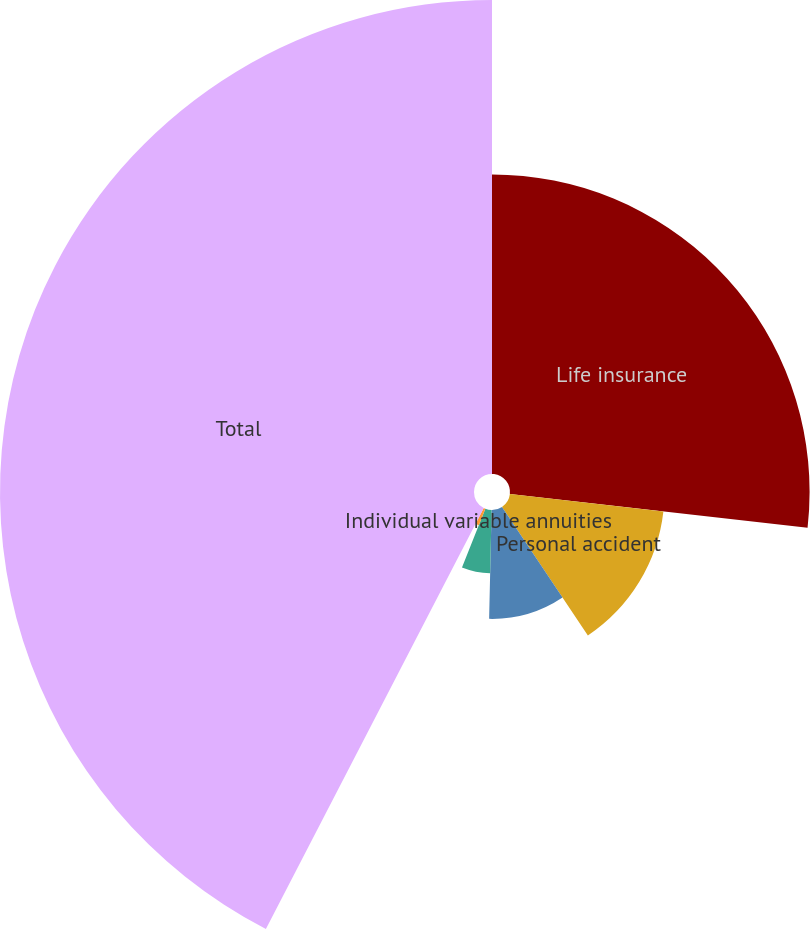Convert chart to OTSL. <chart><loc_0><loc_0><loc_500><loc_500><pie_chart><fcel>Life insurance<fcel>Personal accident<fcel>Group products<fcel>Individual fixed annuities<fcel>Individual variable annuities<fcel>Total<nl><fcel>26.8%<fcel>13.82%<fcel>9.74%<fcel>5.66%<fcel>1.58%<fcel>42.4%<nl></chart> 